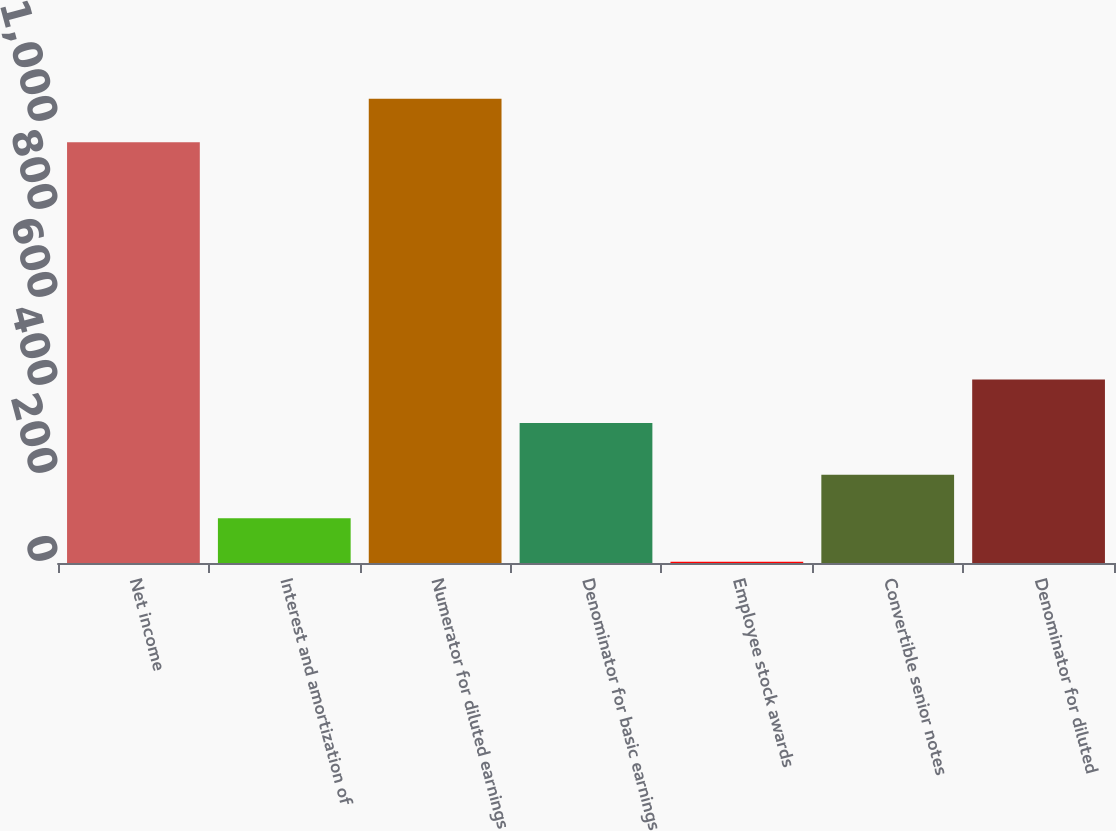<chart> <loc_0><loc_0><loc_500><loc_500><bar_chart><fcel>Net income<fcel>Interest and amortization of<fcel>Numerator for diluted earnings<fcel>Denominator for basic earnings<fcel>Employee stock awards<fcel>Convertible senior notes<fcel>Denominator for diluted<nl><fcel>956.3<fcel>101.65<fcel>1055.35<fcel>318.1<fcel>2.6<fcel>200.7<fcel>417.15<nl></chart> 